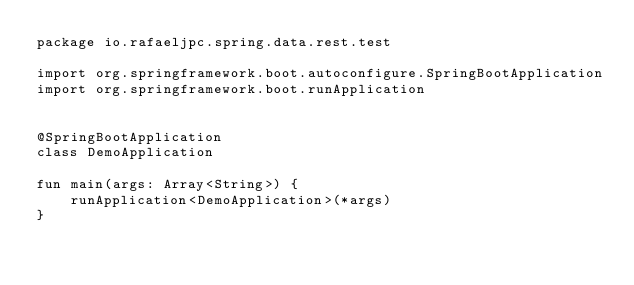Convert code to text. <code><loc_0><loc_0><loc_500><loc_500><_Kotlin_>package io.rafaeljpc.spring.data.rest.test

import org.springframework.boot.autoconfigure.SpringBootApplication
import org.springframework.boot.runApplication


@SpringBootApplication
class DemoApplication

fun main(args: Array<String>) {
	runApplication<DemoApplication>(*args)
}
</code> 